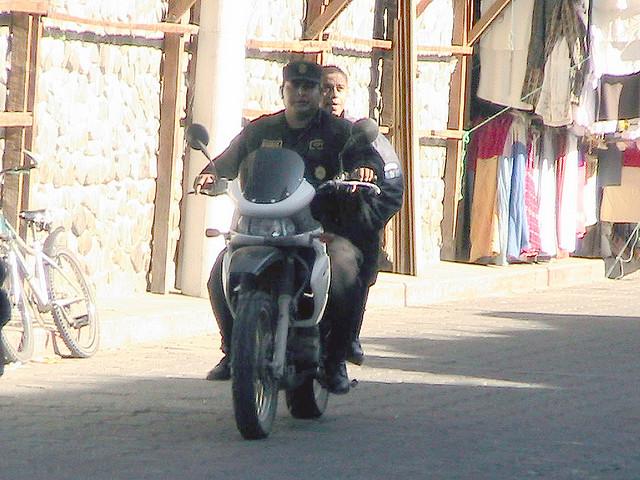Is that clothing in the right corner?
Quick response, please. Yes. How many people on the bike?
Give a very brief answer. 2. What are the men riding in the picture?
Be succinct. Motorcycle. 